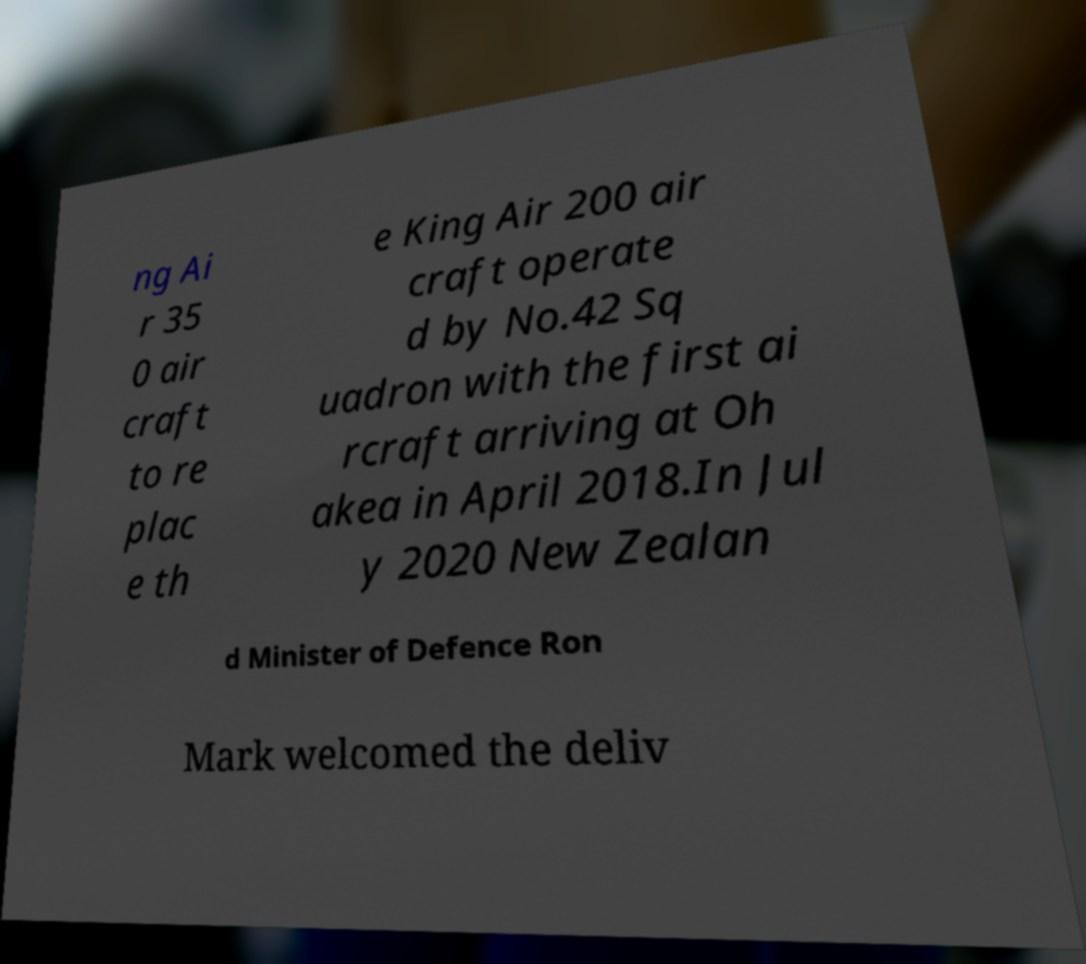For documentation purposes, I need the text within this image transcribed. Could you provide that? ng Ai r 35 0 air craft to re plac e th e King Air 200 air craft operate d by No.42 Sq uadron with the first ai rcraft arriving at Oh akea in April 2018.In Jul y 2020 New Zealan d Minister of Defence Ron Mark welcomed the deliv 